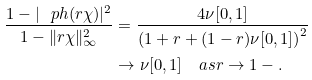Convert formula to latex. <formula><loc_0><loc_0><loc_500><loc_500>\frac { 1 - | \ p h ( r \chi ) | ^ { 2 } } { 1 - \| r \chi \| _ { \infty } ^ { 2 } } & = \frac { 4 \nu [ 0 , 1 ] } { \left ( 1 + r + ( 1 - r ) \nu [ 0 , 1 ] \right ) ^ { 2 } } \\ & \to \nu [ 0 , 1 ] \quad a s r \to 1 - .</formula> 